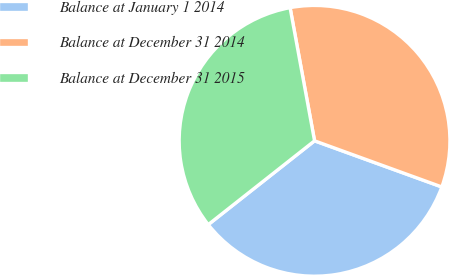<chart> <loc_0><loc_0><loc_500><loc_500><pie_chart><fcel>Balance at January 1 2014<fcel>Balance at December 31 2014<fcel>Balance at December 31 2015<nl><fcel>33.84%<fcel>33.43%<fcel>32.73%<nl></chart> 